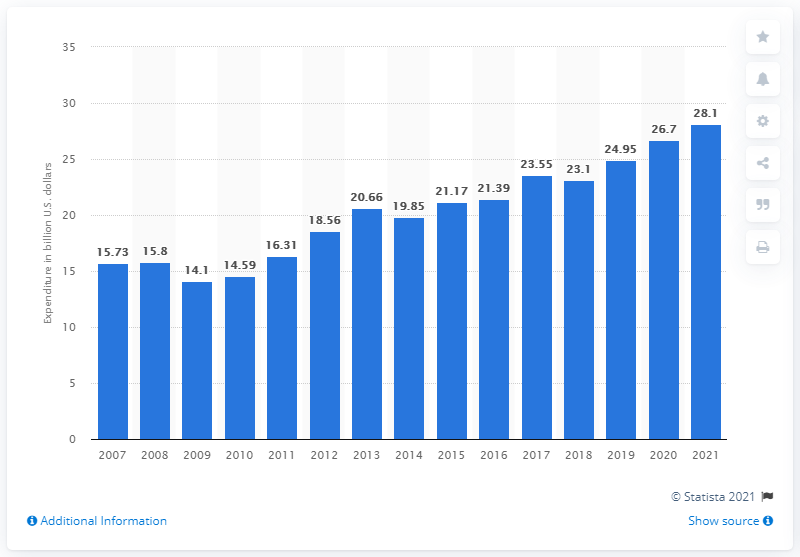List a handful of essential elements in this visual. In 2010, the expenditure on loved ones was 14.59. In 2021, Americans had planned to spend an average of $28.10 on Mother's Day. 